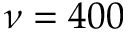<formula> <loc_0><loc_0><loc_500><loc_500>\nu = 4 0 0</formula> 